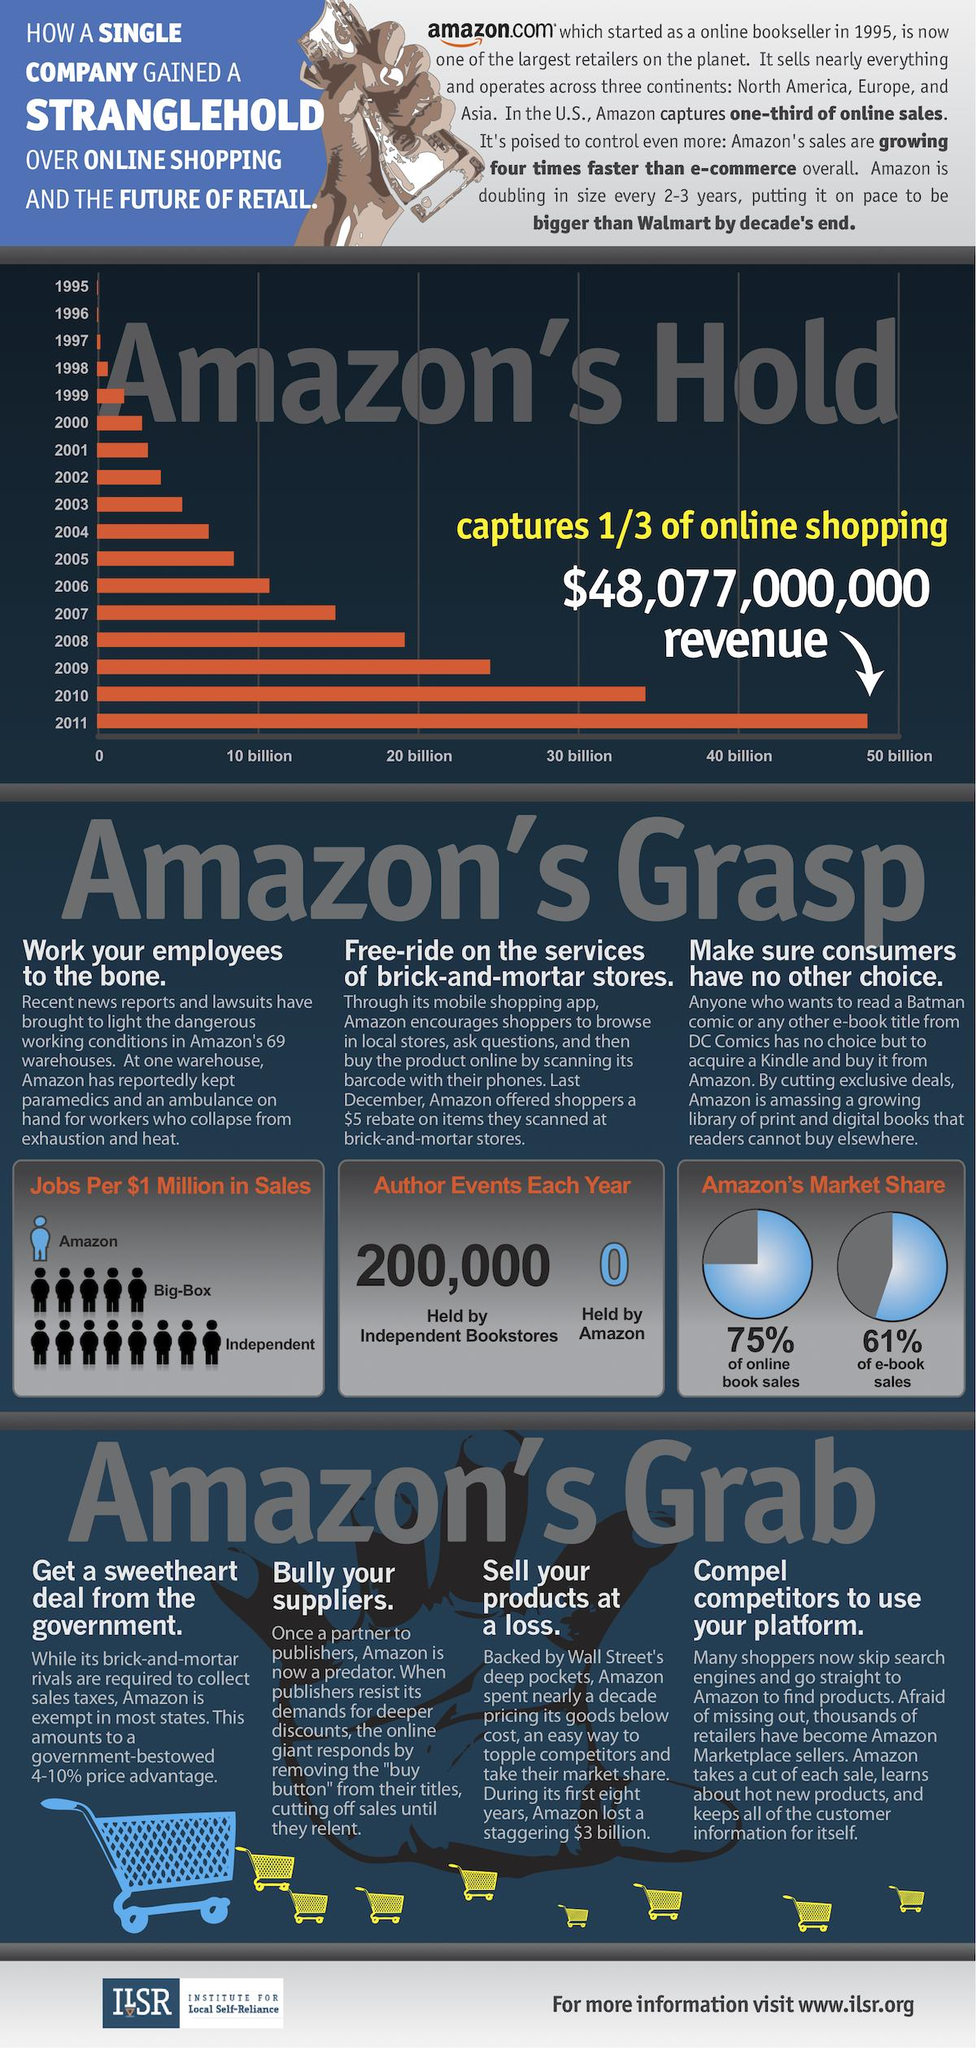Identify some key points in this picture. Amazon holds a dominant 61% market share in e-book sales. Big-Box created an average of 5 jobs for every $1 million in sales. Amazon holds a varying number of author events each year, with zero events held in some years. According to a recent estimate, Amazon has a market share of 75% in online book sales. In the year 2011, Amazon's online shopping generated revenue in excess of $40 billion. 